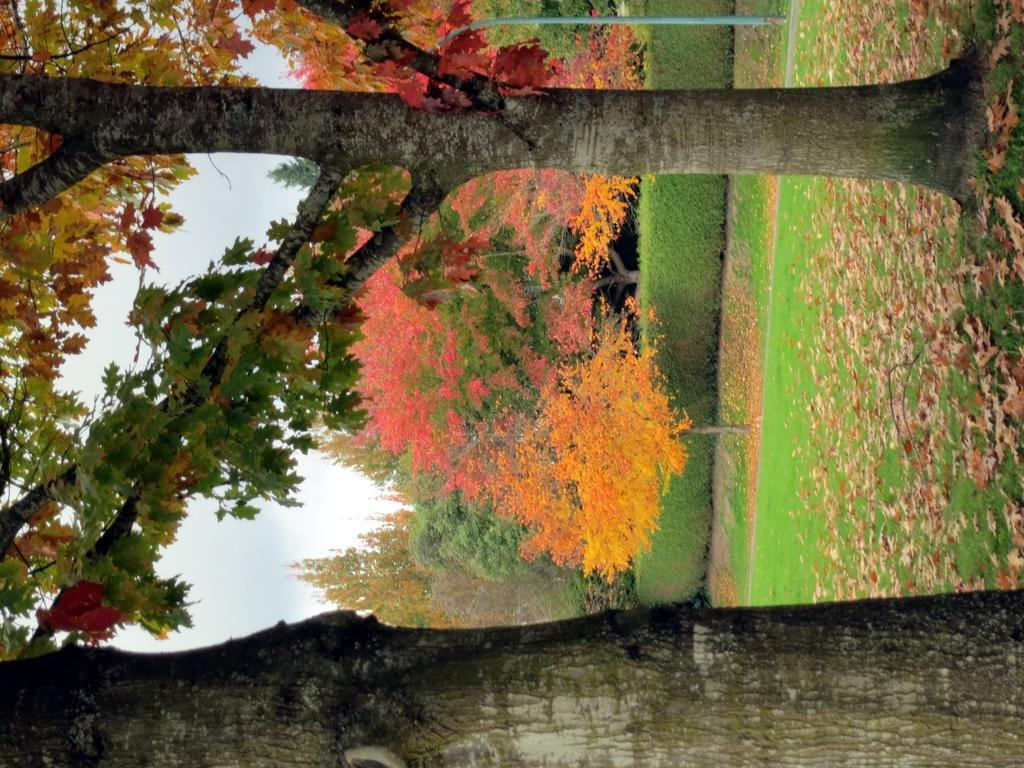What can be seen at the top of the image? The sky is visible in the image. What type of vegetation is present in the image? There are trees and bushes in the image. What is covering the ground in the image? Shredded leaves are present in the image. What is the surface on which the trees and bushes are growing? The ground is visible in the image. Where is the store located in the image? There is no store present in the image. What type of waves can be seen in the image? There are no waves present in the image. 